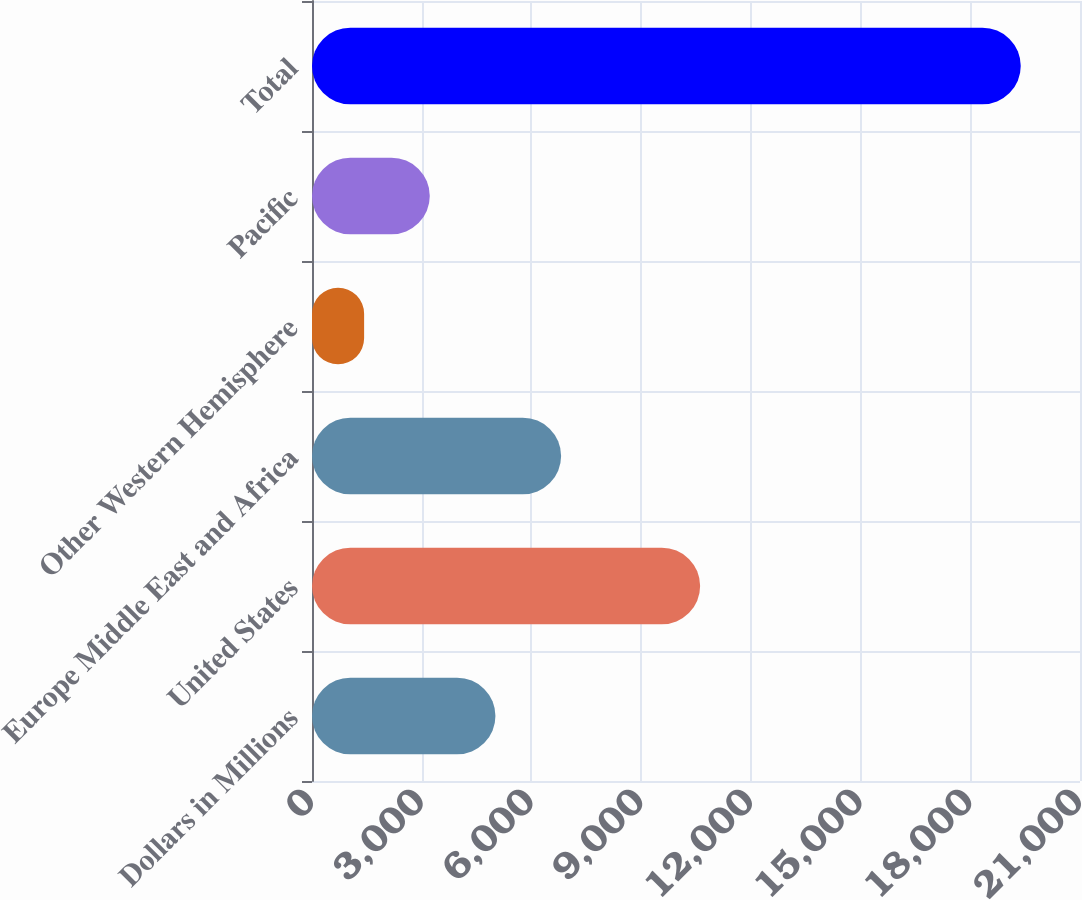<chart> <loc_0><loc_0><loc_500><loc_500><bar_chart><fcel>Dollars in Millions<fcel>United States<fcel>Europe Middle East and Africa<fcel>Other Western Hemisphere<fcel>Pacific<fcel>Total<nl><fcel>5016<fcel>10613<fcel>6811.5<fcel>1425<fcel>3220.5<fcel>19380<nl></chart> 